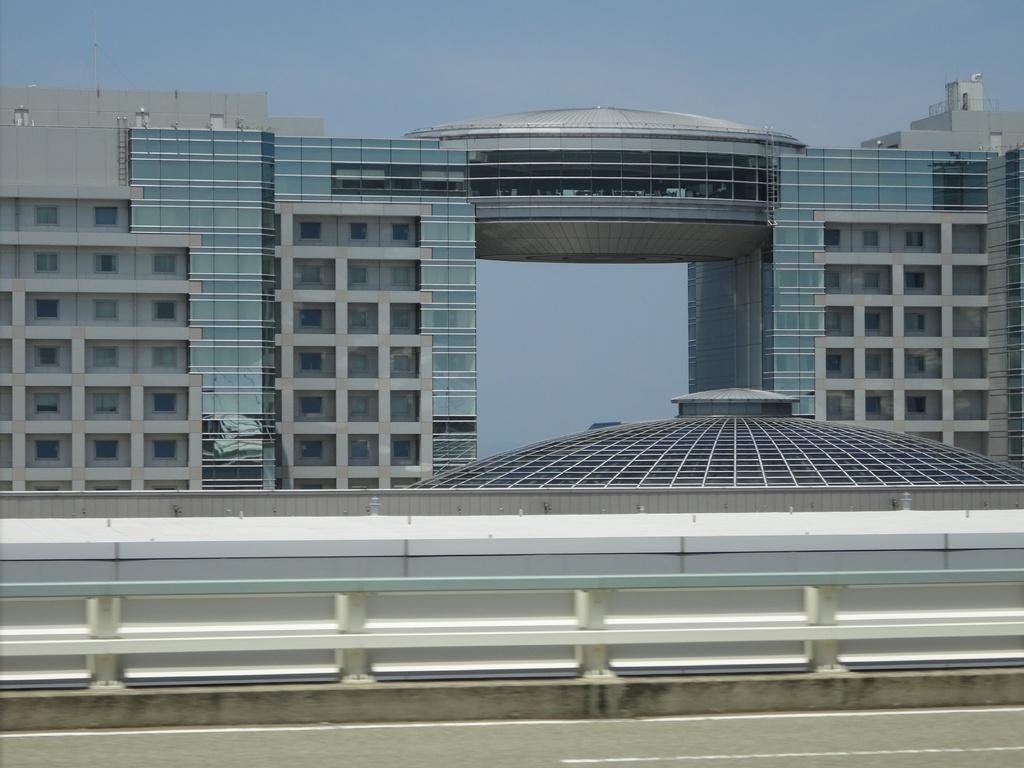What is located at the bottom of the image? There is a road at the bottom of the image. What is beside the road in the image? There is a fence beside the road. What type of buildings can be seen in the background of the image? There are tall buildings with glass in the background of the image. What is visible at the top of the image? The sky is visible at the top of the image. What type of soap is being used for the activity in the image? There is no soap or activity present in the image. What type of doctor can be seen in the image? There is no doctor present in the image. 